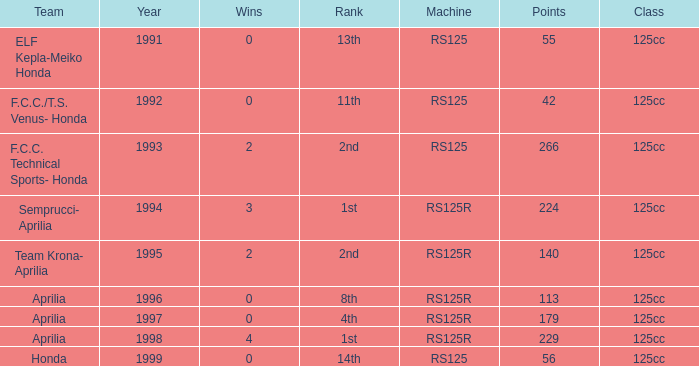Which year had a team of Aprilia and a rank of 4th? 1997.0. 